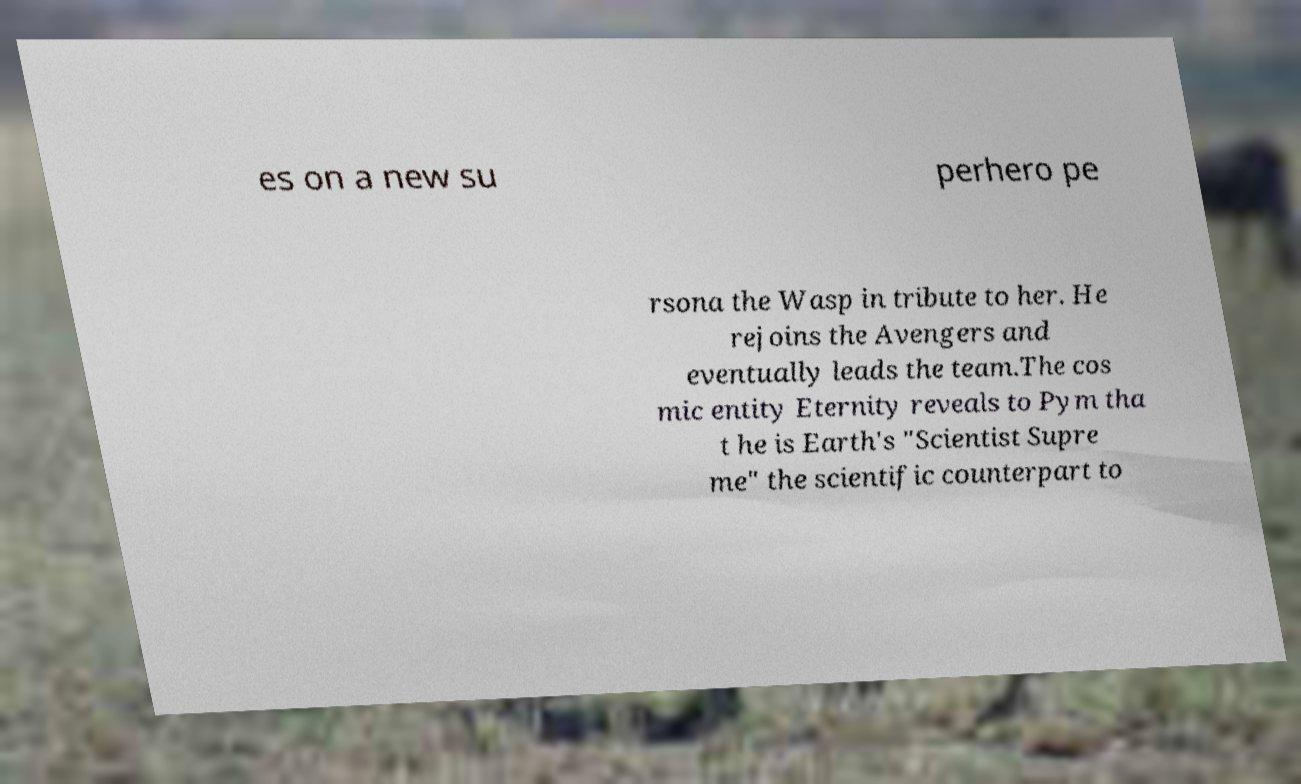For documentation purposes, I need the text within this image transcribed. Could you provide that? es on a new su perhero pe rsona the Wasp in tribute to her. He rejoins the Avengers and eventually leads the team.The cos mic entity Eternity reveals to Pym tha t he is Earth's "Scientist Supre me" the scientific counterpart to 